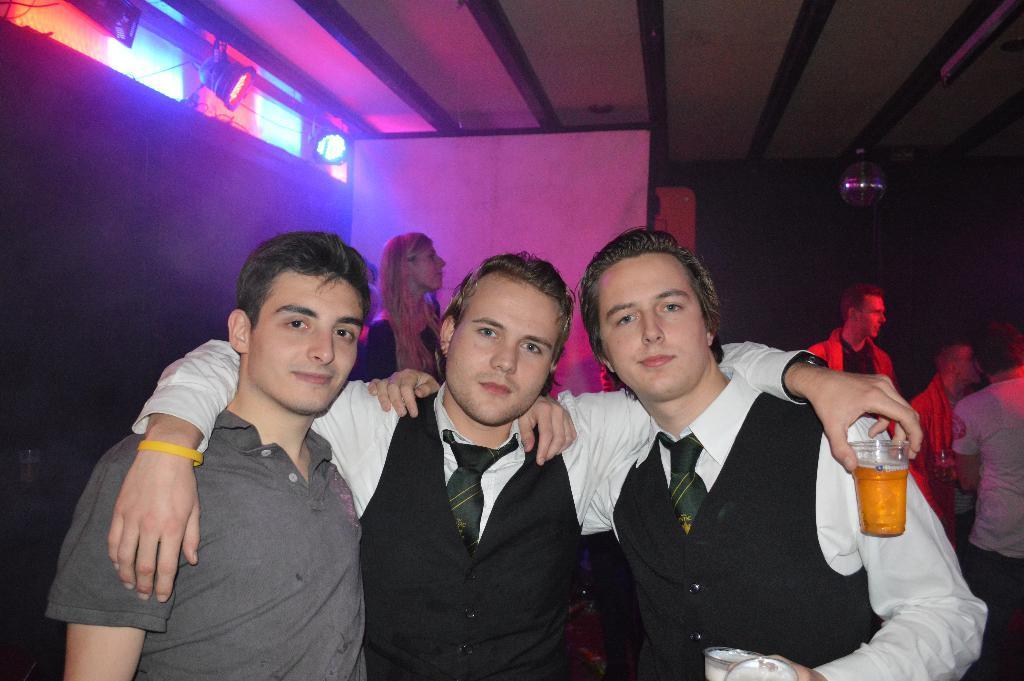Please provide a concise description of this image. In this image I can see three men standing and one man is holding a beer glass. At background I can see a woman standing. At left corner of the image I can see people standing. These are the show lights which are attached to the wall. 